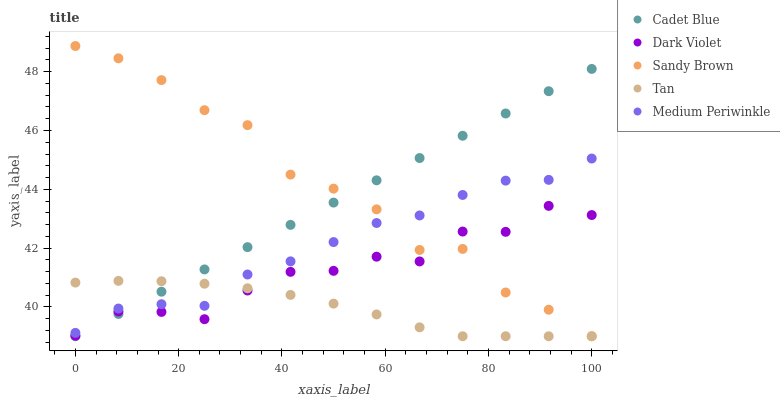Does Tan have the minimum area under the curve?
Answer yes or no. Yes. Does Sandy Brown have the maximum area under the curve?
Answer yes or no. Yes. Does Cadet Blue have the minimum area under the curve?
Answer yes or no. No. Does Cadet Blue have the maximum area under the curve?
Answer yes or no. No. Is Cadet Blue the smoothest?
Answer yes or no. Yes. Is Dark Violet the roughest?
Answer yes or no. Yes. Is Tan the smoothest?
Answer yes or no. No. Is Tan the roughest?
Answer yes or no. No. Does Tan have the lowest value?
Answer yes or no. Yes. Does Dark Violet have the lowest value?
Answer yes or no. No. Does Sandy Brown have the highest value?
Answer yes or no. Yes. Does Cadet Blue have the highest value?
Answer yes or no. No. Is Dark Violet less than Medium Periwinkle?
Answer yes or no. Yes. Is Medium Periwinkle greater than Dark Violet?
Answer yes or no. Yes. Does Tan intersect Cadet Blue?
Answer yes or no. Yes. Is Tan less than Cadet Blue?
Answer yes or no. No. Is Tan greater than Cadet Blue?
Answer yes or no. No. Does Dark Violet intersect Medium Periwinkle?
Answer yes or no. No. 